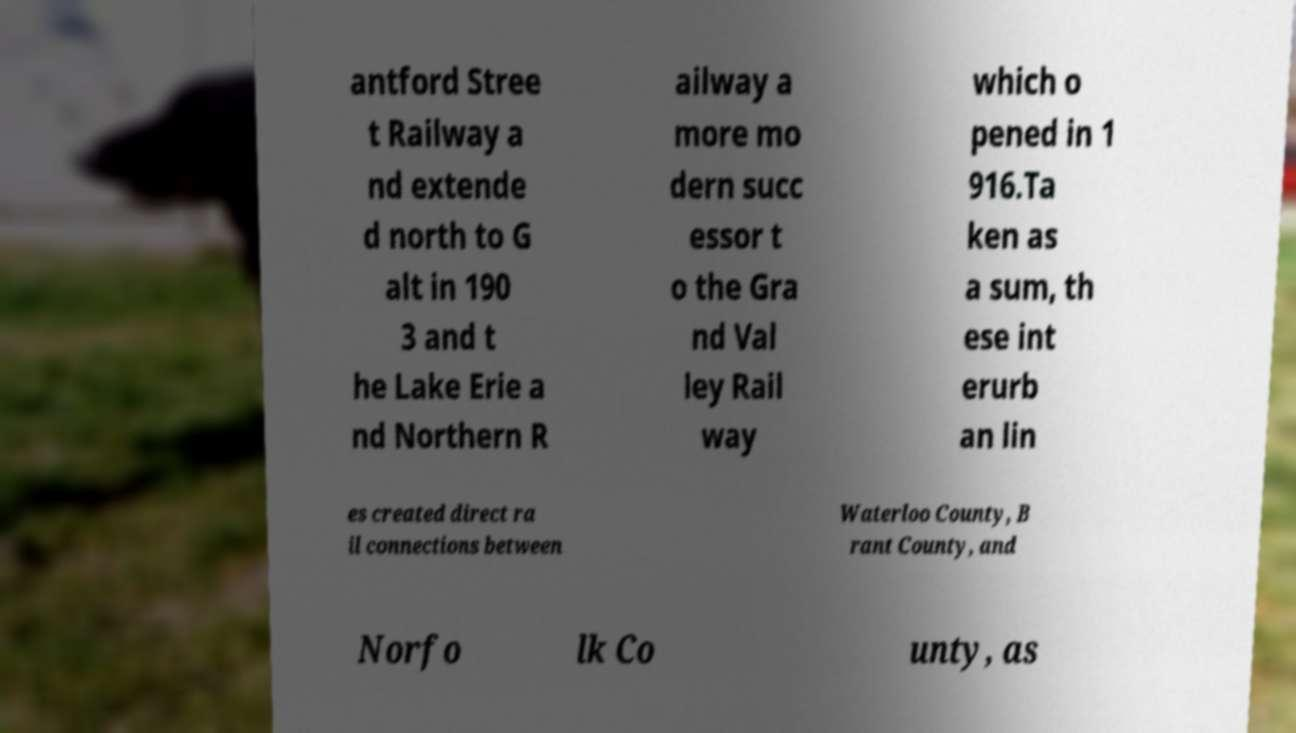Could you assist in decoding the text presented in this image and type it out clearly? antford Stree t Railway a nd extende d north to G alt in 190 3 and t he Lake Erie a nd Northern R ailway a more mo dern succ essor t o the Gra nd Val ley Rail way which o pened in 1 916.Ta ken as a sum, th ese int erurb an lin es created direct ra il connections between Waterloo County, B rant County, and Norfo lk Co unty, as 